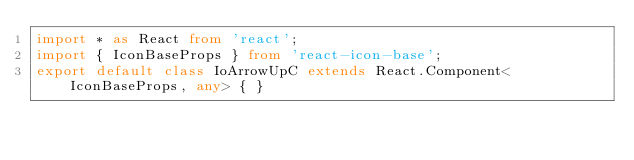<code> <loc_0><loc_0><loc_500><loc_500><_TypeScript_>import * as React from 'react';
import { IconBaseProps } from 'react-icon-base';
export default class IoArrowUpC extends React.Component<IconBaseProps, any> { }
</code> 